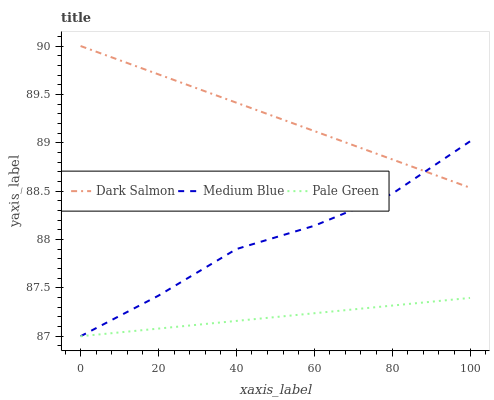Does Pale Green have the minimum area under the curve?
Answer yes or no. Yes. Does Dark Salmon have the maximum area under the curve?
Answer yes or no. Yes. Does Medium Blue have the minimum area under the curve?
Answer yes or no. No. Does Medium Blue have the maximum area under the curve?
Answer yes or no. No. Is Pale Green the smoothest?
Answer yes or no. Yes. Is Medium Blue the roughest?
Answer yes or no. Yes. Is Dark Salmon the smoothest?
Answer yes or no. No. Is Dark Salmon the roughest?
Answer yes or no. No. Does Dark Salmon have the lowest value?
Answer yes or no. No. Does Medium Blue have the highest value?
Answer yes or no. No. Is Pale Green less than Dark Salmon?
Answer yes or no. Yes. Is Dark Salmon greater than Pale Green?
Answer yes or no. Yes. Does Pale Green intersect Dark Salmon?
Answer yes or no. No. 